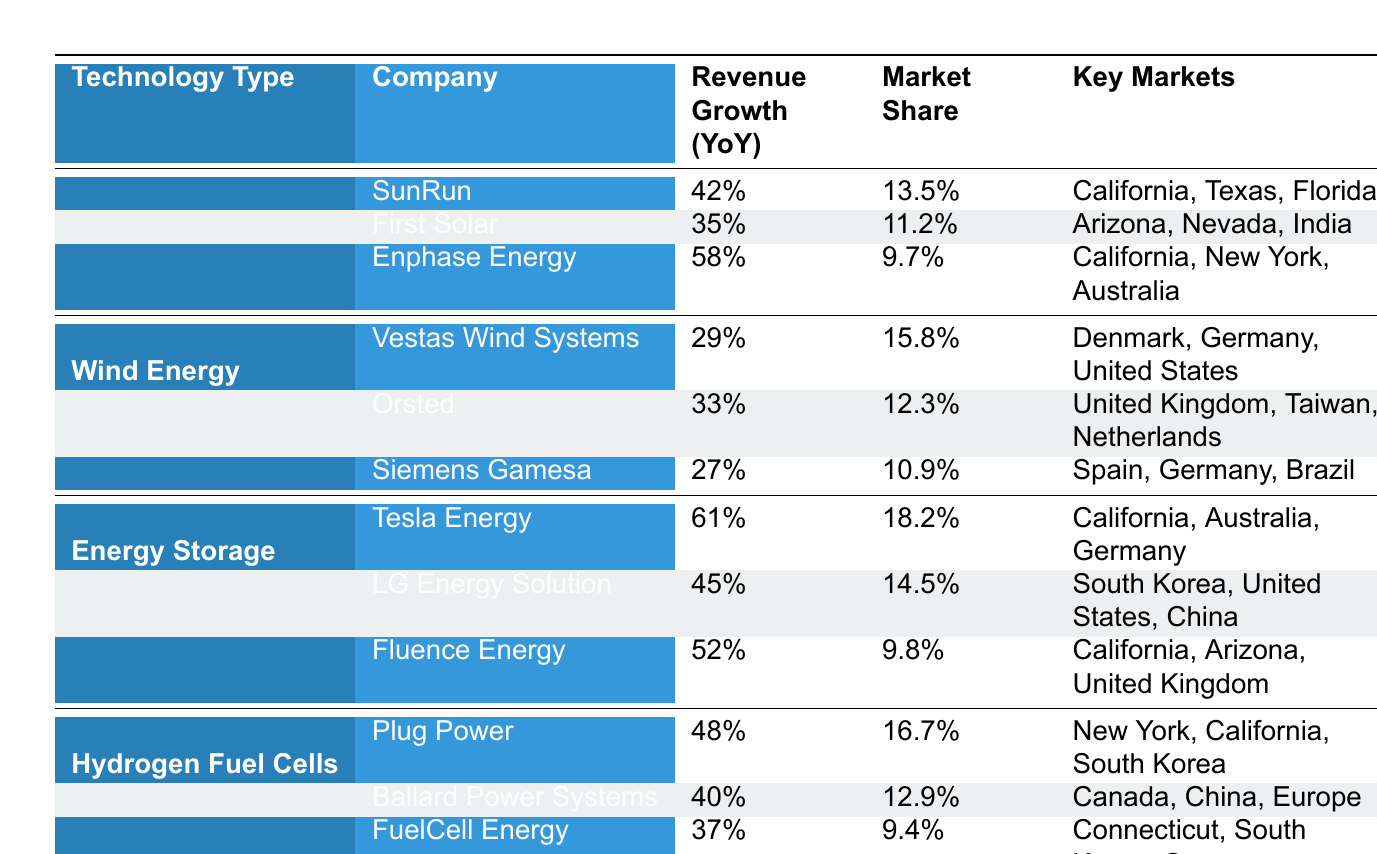What is the revenue growth percentage for Tesla Energy? The table shows that Tesla Energy has a revenue growth of 61% year-over-year.
Answer: 61% Which company has the highest market share in Energy Storage? According to the table, Tesla Energy holds the highest market share in Energy Storage at 18.2%.
Answer: 18.2% What is the average revenue growth for companies in Wind Energy? The revenue growth percentages for Wind Energy companies are 29%, 33%, and 27%. The average is (29 + 33 + 27) / 3 = 29.67%.
Answer: 29.67% Does Plug Power have a higher market share than Ballard Power Systems? Plug Power has a market share of 16.7%, while Ballard Power Systems has a market share of 12.9%. Therefore, Yes, Plug Power has a higher market share.
Answer: Yes Which company in Solar Photovoltaics has the lowest revenue growth? The revenue growth for Solar Photovoltaics companies are 42%, 35%, and 58%. First Solar has the lowest growth at 35%.
Answer: 35% What is the total revenue growth percentage for all companies in Hydrogen Fuel Cells? The revenue growth percentages for Hydrogen Fuel Cells companies are 48%, 40%, and 37%. The total is (48 + 40 + 37) = 125%.
Answer: 125% Which technology type has the highest average market share? To find the average market share, we calculate for each technology: Solar Photovoltaics = (13.5 + 11.2 + 9.7) / 3 = 11.47%, Wind Energy = (15.8 + 12.3 + 10.9) / 3 = 13.33%, Energy Storage = (18.2 + 14.5 + 9.8) / 3 = 14.5%, Hydrogen Fuel Cells = (16.7 + 12.9 + 9.4) / 3 = 13.67%. Energy Storage has the highest average at 14.5%.
Answer: Energy Storage Is the market share of Enphase Energy greater than 10%? Enphase Energy has a market share of 9.7%, which is less than 10%.
Answer: No Which company has the highest revenue growth rate and what is it? Looking at the table, Tesla Energy has the highest revenue growth at 61%.
Answer: Tesla Energy, 61% 